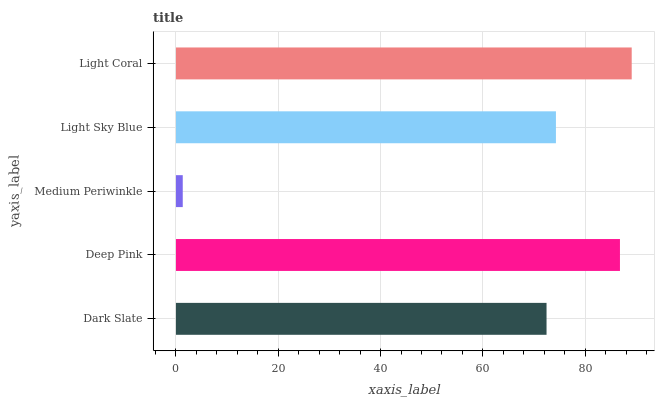Is Medium Periwinkle the minimum?
Answer yes or no. Yes. Is Light Coral the maximum?
Answer yes or no. Yes. Is Deep Pink the minimum?
Answer yes or no. No. Is Deep Pink the maximum?
Answer yes or no. No. Is Deep Pink greater than Dark Slate?
Answer yes or no. Yes. Is Dark Slate less than Deep Pink?
Answer yes or no. Yes. Is Dark Slate greater than Deep Pink?
Answer yes or no. No. Is Deep Pink less than Dark Slate?
Answer yes or no. No. Is Light Sky Blue the high median?
Answer yes or no. Yes. Is Light Sky Blue the low median?
Answer yes or no. Yes. Is Deep Pink the high median?
Answer yes or no. No. Is Dark Slate the low median?
Answer yes or no. No. 